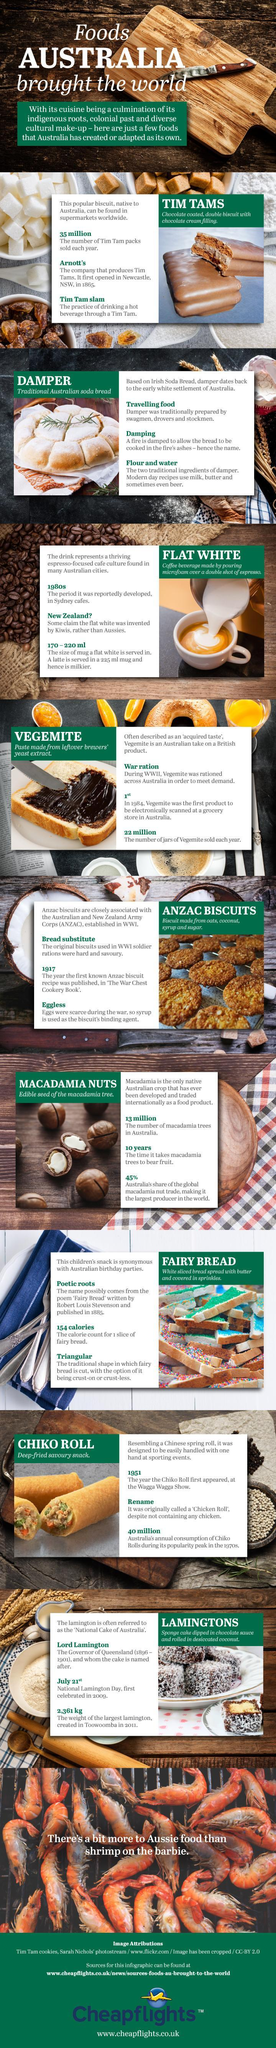What was the original name of Chiko Roll?
Answer the question with a short phrase. Chicken Roll Which bread is cooked over a damped fire's ashes? Damper Name the coffee beverage which was reportedly developed in 1980s in Sydney cafes Flat White Which food item is sold more each year - Tim Tam or Vegemite? Tim Tam What is the outermost coating on a Lamington cake? desiccated coconut Which biscuits were used in WWI soldier rations? Anzac In which biscuit's recipe is syrup used as the binding agent? Anzac biscuit Which food item was originally called chicken roll though it doesn't contain chicken? Chiko Roll Which is served in a bigger mug - latte or flat white? latte 